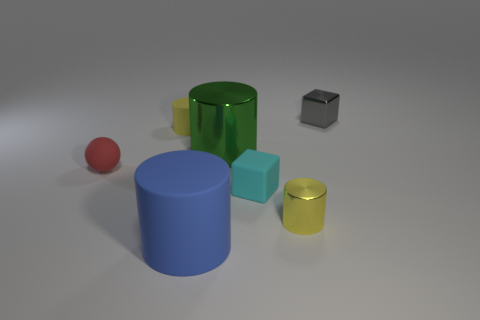Is the tiny cyan thing made of the same material as the small red thing?
Ensure brevity in your answer.  Yes. There is a large blue cylinder; are there any gray cubes right of it?
Offer a very short reply. Yes. The cylinder in front of the yellow cylinder right of the large matte cylinder is made of what material?
Provide a succinct answer. Rubber. What is the size of the cyan object that is the same shape as the gray metal object?
Your response must be concise. Small. Do the metallic block and the tiny sphere have the same color?
Give a very brief answer. No. There is a shiny thing that is behind the tiny matte sphere and in front of the tiny metal cube; what color is it?
Your answer should be very brief. Green. There is a cylinder that is behind the green object; is its size the same as the small red rubber sphere?
Give a very brief answer. Yes. Are there any other things that have the same shape as the small yellow metallic object?
Your answer should be compact. Yes. Are the small red object and the tiny cube that is in front of the tiny gray object made of the same material?
Make the answer very short. Yes. How many gray things are tiny things or metallic cubes?
Provide a short and direct response. 1. 